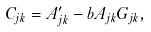<formula> <loc_0><loc_0><loc_500><loc_500>C _ { j k } = A ^ { \prime } _ { j k } - b A _ { j k } G _ { j k } ,</formula> 